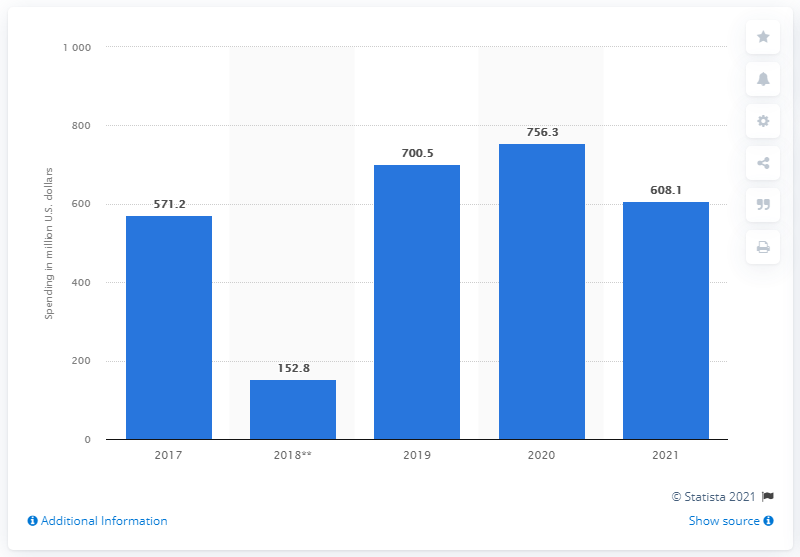Draw attention to some important aspects in this diagram. In 2021, VF Corporation spent 608.1 million dollars on advertising. 